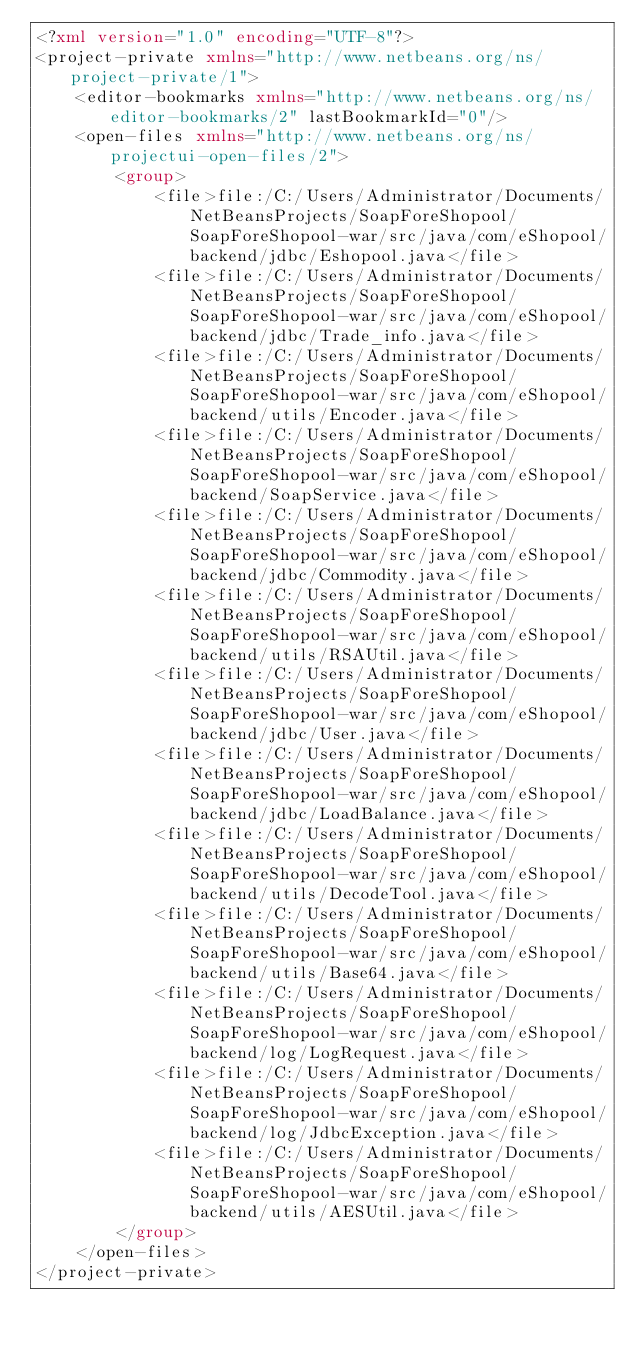Convert code to text. <code><loc_0><loc_0><loc_500><loc_500><_XML_><?xml version="1.0" encoding="UTF-8"?>
<project-private xmlns="http://www.netbeans.org/ns/project-private/1">
    <editor-bookmarks xmlns="http://www.netbeans.org/ns/editor-bookmarks/2" lastBookmarkId="0"/>
    <open-files xmlns="http://www.netbeans.org/ns/projectui-open-files/2">
        <group>
            <file>file:/C:/Users/Administrator/Documents/NetBeansProjects/SoapForeShopool/SoapForeShopool-war/src/java/com/eShopool/backend/jdbc/Eshopool.java</file>
            <file>file:/C:/Users/Administrator/Documents/NetBeansProjects/SoapForeShopool/SoapForeShopool-war/src/java/com/eShopool/backend/jdbc/Trade_info.java</file>
            <file>file:/C:/Users/Administrator/Documents/NetBeansProjects/SoapForeShopool/SoapForeShopool-war/src/java/com/eShopool/backend/utils/Encoder.java</file>
            <file>file:/C:/Users/Administrator/Documents/NetBeansProjects/SoapForeShopool/SoapForeShopool-war/src/java/com/eShopool/backend/SoapService.java</file>
            <file>file:/C:/Users/Administrator/Documents/NetBeansProjects/SoapForeShopool/SoapForeShopool-war/src/java/com/eShopool/backend/jdbc/Commodity.java</file>
            <file>file:/C:/Users/Administrator/Documents/NetBeansProjects/SoapForeShopool/SoapForeShopool-war/src/java/com/eShopool/backend/utils/RSAUtil.java</file>
            <file>file:/C:/Users/Administrator/Documents/NetBeansProjects/SoapForeShopool/SoapForeShopool-war/src/java/com/eShopool/backend/jdbc/User.java</file>
            <file>file:/C:/Users/Administrator/Documents/NetBeansProjects/SoapForeShopool/SoapForeShopool-war/src/java/com/eShopool/backend/jdbc/LoadBalance.java</file>
            <file>file:/C:/Users/Administrator/Documents/NetBeansProjects/SoapForeShopool/SoapForeShopool-war/src/java/com/eShopool/backend/utils/DecodeTool.java</file>
            <file>file:/C:/Users/Administrator/Documents/NetBeansProjects/SoapForeShopool/SoapForeShopool-war/src/java/com/eShopool/backend/utils/Base64.java</file>
            <file>file:/C:/Users/Administrator/Documents/NetBeansProjects/SoapForeShopool/SoapForeShopool-war/src/java/com/eShopool/backend/log/LogRequest.java</file>
            <file>file:/C:/Users/Administrator/Documents/NetBeansProjects/SoapForeShopool/SoapForeShopool-war/src/java/com/eShopool/backend/log/JdbcException.java</file>
            <file>file:/C:/Users/Administrator/Documents/NetBeansProjects/SoapForeShopool/SoapForeShopool-war/src/java/com/eShopool/backend/utils/AESUtil.java</file>
        </group>
    </open-files>
</project-private>
</code> 